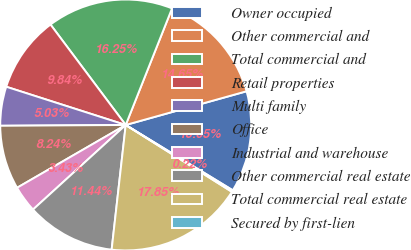<chart> <loc_0><loc_0><loc_500><loc_500><pie_chart><fcel>Owner occupied<fcel>Other commercial and<fcel>Total commercial and<fcel>Retail properties<fcel>Multi family<fcel>Office<fcel>Industrial and warehouse<fcel>Other commercial real estate<fcel>Total commercial real estate<fcel>Secured by first-lien<nl><fcel>13.05%<fcel>14.65%<fcel>16.25%<fcel>9.84%<fcel>5.03%<fcel>8.24%<fcel>3.43%<fcel>11.44%<fcel>17.85%<fcel>0.22%<nl></chart> 